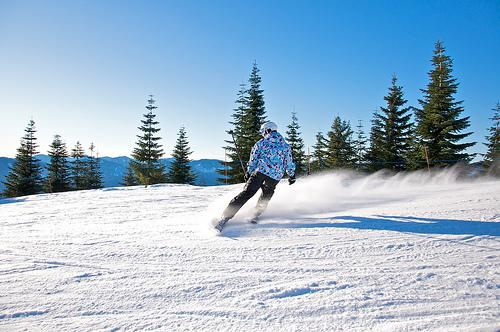Question: what is on the ground?
Choices:
A. Snow.
B. Dirt.
C. Sand.
D. Seeds.
Answer with the letter. Answer: A Question: how many clouds are in the sky?
Choices:
A. 20.
B. 30.
C. 40.
D. None.
Answer with the letter. Answer: D Question: what is the person doing?
Choices:
A. Surfing.
B. Skiing.
C. Skating.
D. Shopping.
Answer with the letter. Answer: B Question: who is casting a shadow on the ground?
Choices:
A. The runner.
B. The jogger.
C. The sledder.
D. The skier.
Answer with the letter. Answer: D Question: what is lined up at the edge of the snow?
Choices:
A. Trees.
B. Grass.
C. Bushes.
D. Vines.
Answer with the letter. Answer: A 